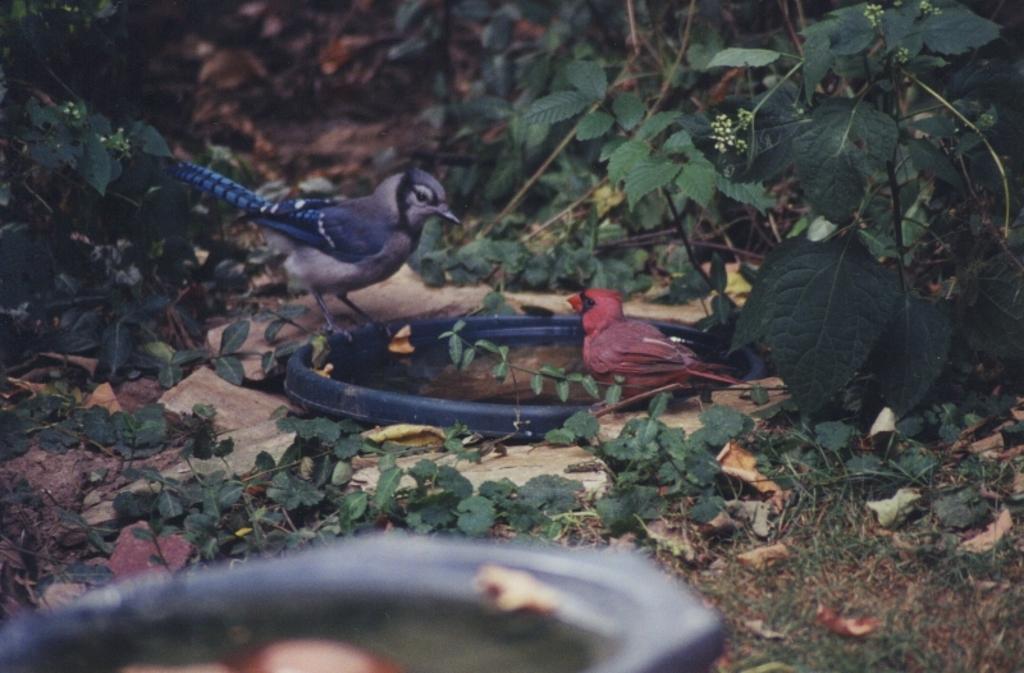Could you give a brief overview of what you see in this image? In this image I can see two birds which are in blue and red color. These are standing on the blue color bowl. To the side I can see many trees. 